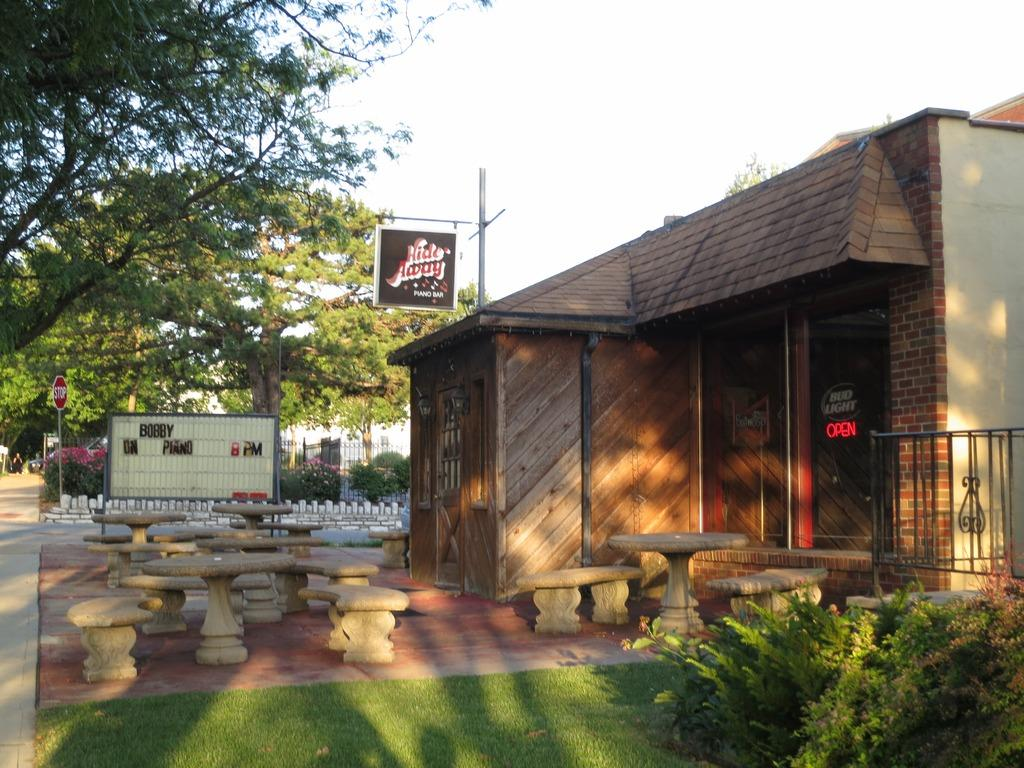What type of structure is visible in the image? There is a house in the image. What is located near the house? There is a name board in the image. What can be used for sitting in the image? There are benches in the image. What type of ground surface is present in the image? There is grass in the image. What type of vegetation is present in the image? There are plants in the image. What type of pathway is visible in the image? There is a road in the image. What type of container is visible in the image? There is a container in the image. What type of sign is visible in the image? There is a signboard in the image. What type of tall vegetation is present in the image? There are trees in the image. What part of the natural environment is visible in the image? The sky is visible in the image. Can you tell me how many farmers are talking to each other in the image? There are no farmers present in the image, nor is there any indication of people talking. What type of tree is growing on the roof of the house in the image? There is no tree growing on the roof of the house in the image. 